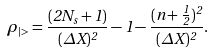<formula> <loc_0><loc_0><loc_500><loc_500>\rho _ { | > } = \frac { ( 2 N _ { s } + 1 ) } { ( \Delta X ) ^ { 2 } } - 1 - \frac { ( n + \frac { 1 } { 2 } ) ^ { 2 } } { ( \Delta X ) ^ { 2 } } .</formula> 